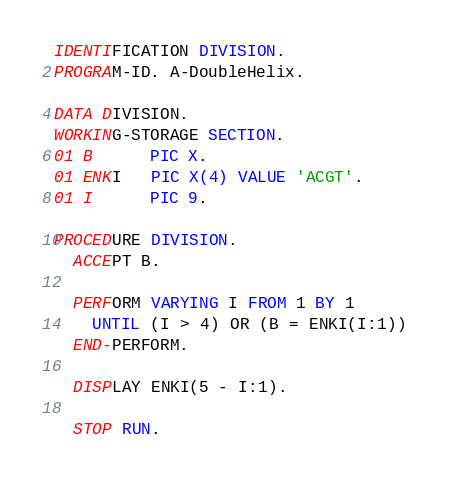Convert code to text. <code><loc_0><loc_0><loc_500><loc_500><_COBOL_>IDENTIFICATION DIVISION.
PROGRAM-ID. A-DoubleHelix.
 
DATA DIVISION.
WORKING-STORAGE SECTION.
01 B      PIC X.
01 ENKI   PIC X(4) VALUE 'ACGT'.
01 I      PIC 9.
 
PROCEDURE DIVISION.
  ACCEPT B.

  PERFORM VARYING I FROM 1 BY 1
    UNTIL (I > 4) OR (B = ENKI(I:1))
  END-PERFORM.

  DISPLAY ENKI(5 - I:1).

  STOP RUN.
</code> 